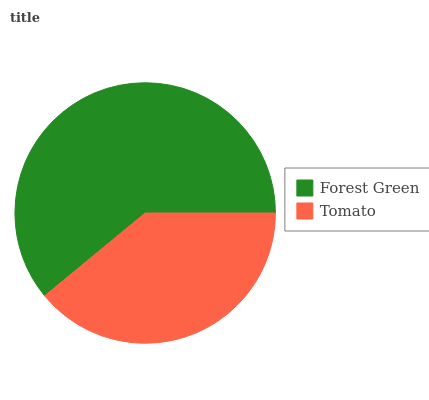Is Tomato the minimum?
Answer yes or no. Yes. Is Forest Green the maximum?
Answer yes or no. Yes. Is Tomato the maximum?
Answer yes or no. No. Is Forest Green greater than Tomato?
Answer yes or no. Yes. Is Tomato less than Forest Green?
Answer yes or no. Yes. Is Tomato greater than Forest Green?
Answer yes or no. No. Is Forest Green less than Tomato?
Answer yes or no. No. Is Forest Green the high median?
Answer yes or no. Yes. Is Tomato the low median?
Answer yes or no. Yes. Is Tomato the high median?
Answer yes or no. No. Is Forest Green the low median?
Answer yes or no. No. 